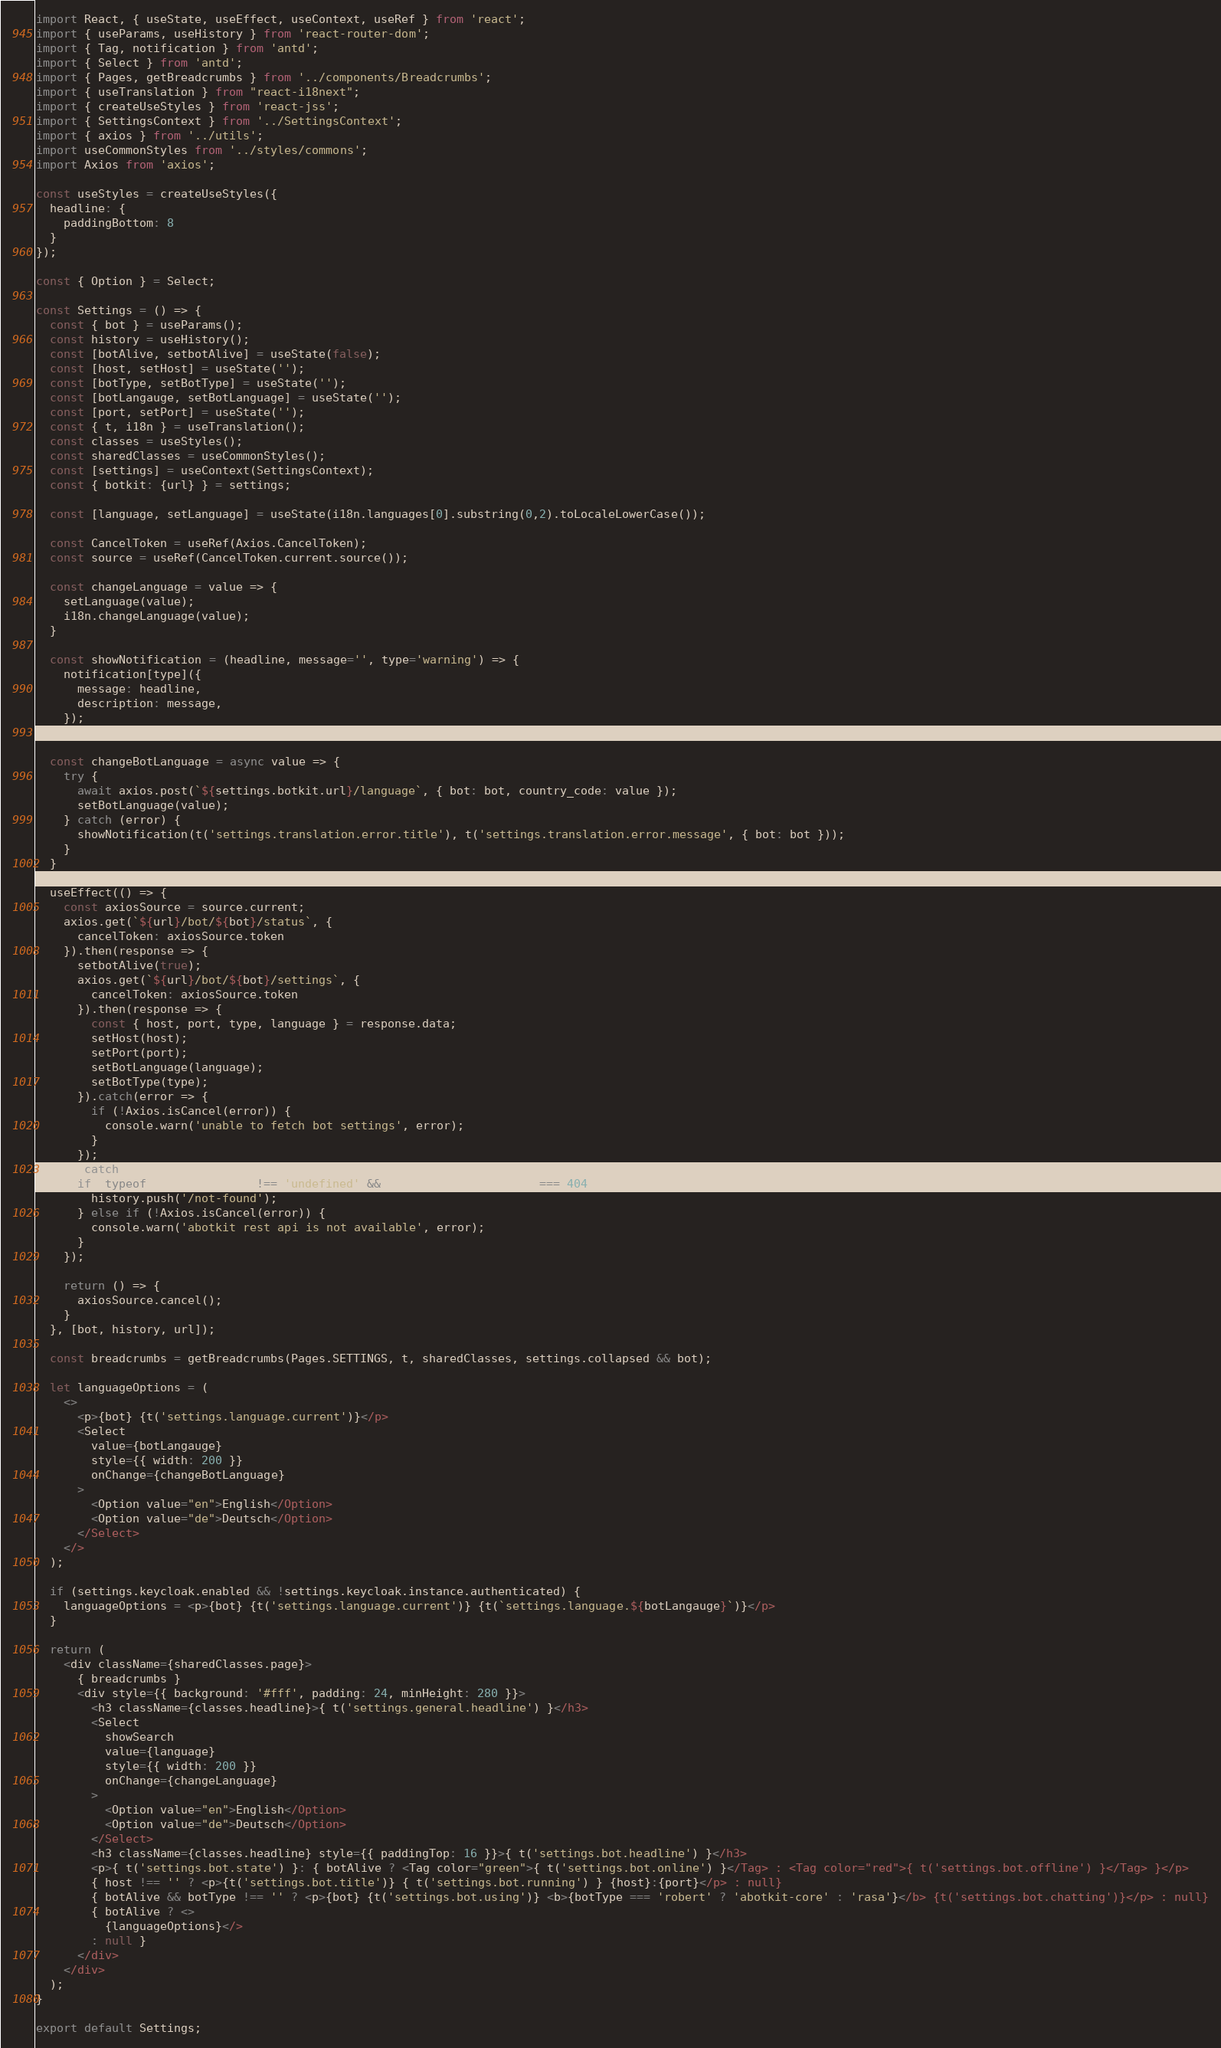Convert code to text. <code><loc_0><loc_0><loc_500><loc_500><_JavaScript_>import React, { useState, useEffect, useContext, useRef } from 'react';
import { useParams, useHistory } from 'react-router-dom';
import { Tag, notification } from 'antd';
import { Select } from 'antd';
import { Pages, getBreadcrumbs } from '../components/Breadcrumbs';
import { useTranslation } from "react-i18next";
import { createUseStyles } from 'react-jss';
import { SettingsContext } from '../SettingsContext';
import { axios } from '../utils';
import useCommonStyles from '../styles/commons';
import Axios from 'axios';

const useStyles = createUseStyles({
  headline: {
    paddingBottom: 8
  }
});

const { Option } = Select;

const Settings = () => {
  const { bot } = useParams();
  const history = useHistory();
  const [botAlive, setbotAlive] = useState(false);
  const [host, setHost] = useState('');
  const [botType, setBotType] = useState('');
  const [botLangauge, setBotLanguage] = useState('');
  const [port, setPort] = useState('');
  const { t, i18n } = useTranslation();
  const classes = useStyles();
  const sharedClasses = useCommonStyles();
  const [settings] = useContext(SettingsContext);
  const { botkit: {url} } = settings;

  const [language, setLanguage] = useState(i18n.languages[0].substring(0,2).toLocaleLowerCase());
  
  const CancelToken = useRef(Axios.CancelToken);
  const source = useRef(CancelToken.current.source());

  const changeLanguage = value => {
    setLanguage(value);
    i18n.changeLanguage(value);
  }

  const showNotification = (headline, message='', type='warning') => {
    notification[type]({
      message: headline,
      description: message,
    });
  };

  const changeBotLanguage = async value => {
    try {
      await axios.post(`${settings.botkit.url}/language`, { bot: bot, country_code: value });
      setBotLanguage(value);
    } catch (error) {
      showNotification(t('settings.translation.error.title'), t('settings.translation.error.message', { bot: bot }));
    }
  }

  useEffect(() => {
    const axiosSource = source.current;
    axios.get(`${url}/bot/${bot}/status`, {
      cancelToken: axiosSource.token
    }).then(response => {
      setbotAlive(true);
      axios.get(`${url}/bot/${bot}/settings`, {
        cancelToken: axiosSource.token
      }).then(response => {
        const { host, port, type, language } = response.data;
        setHost(host);
        setPort(port);
        setBotLanguage(language);
        setBotType(type);
      }).catch(error => {
        if (!Axios.isCancel(error)) {
          console.warn('unable to fetch bot settings', error);
        }
      });
    }).catch(error => {
      if (typeof error.response !== 'undefined' && error.response.status === 404) {
        history.push('/not-found');
      } else if (!Axios.isCancel(error)) {
        console.warn('abotkit rest api is not available', error);
      }
    });

    return () => {
      axiosSource.cancel();
    }
  }, [bot, history, url]);

  const breadcrumbs = getBreadcrumbs(Pages.SETTINGS, t, sharedClasses, settings.collapsed && bot);

  let languageOptions = (
    <>
      <p>{bot} {t('settings.language.current')}</p>
      <Select
        value={botLangauge}
        style={{ width: 200 }}
        onChange={changeBotLanguage}
      >
        <Option value="en">English</Option>
        <Option value="de">Deutsch</Option>
      </Select>
    </>
  );
  
  if (settings.keycloak.enabled && !settings.keycloak.instance.authenticated) {
    languageOptions = <p>{bot} {t('settings.language.current')} {t(`settings.language.${botLangauge}`)}</p>
  }

  return (
    <div className={sharedClasses.page}>
      { breadcrumbs }
      <div style={{ background: '#fff', padding: 24, minHeight: 280 }}>
        <h3 className={classes.headline}>{ t('settings.general.headline') }</h3>
        <Select
          showSearch
          value={language}
          style={{ width: 200 }}
          onChange={changeLanguage}
        >
          <Option value="en">English</Option>
          <Option value="de">Deutsch</Option>
        </Select>
        <h3 className={classes.headline} style={{ paddingTop: 16 }}>{ t('settings.bot.headline') }</h3>
        <p>{ t('settings.bot.state') }: { botAlive ? <Tag color="green">{ t('settings.bot.online') }</Tag> : <Tag color="red">{ t('settings.bot.offline') }</Tag> }</p>
        { host !== '' ? <p>{t('settings.bot.title')} { t('settings.bot.running') } {host}:{port}</p> : null}
        { botAlive && botType !== '' ? <p>{bot} {t('settings.bot.using')} <b>{botType === 'robert' ? 'abotkit-core' : 'rasa'}</b> {t('settings.bot.chatting')}</p> : null}
        { botAlive ? <>
          {languageOptions}</> 
        : null }
      </div>
    </div>
  );
}

export default Settings;
</code> 